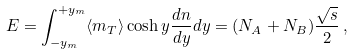Convert formula to latex. <formula><loc_0><loc_0><loc_500><loc_500>E = \int _ { - y _ { m } } ^ { + y _ { m } } \langle m _ { T } \rangle \cosh y \frac { d n } { d y } d y = ( N _ { A } + N _ { B } ) \frac { \sqrt { s } } { 2 } \, ,</formula> 